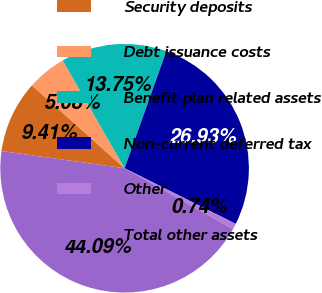Convert chart. <chart><loc_0><loc_0><loc_500><loc_500><pie_chart><fcel>Security deposits<fcel>Debt issuance costs<fcel>Benefit plan related assets<fcel>Non-current deferred tax<fcel>Other<fcel>Total other assets<nl><fcel>9.41%<fcel>5.08%<fcel>13.75%<fcel>26.93%<fcel>0.74%<fcel>44.09%<nl></chart> 